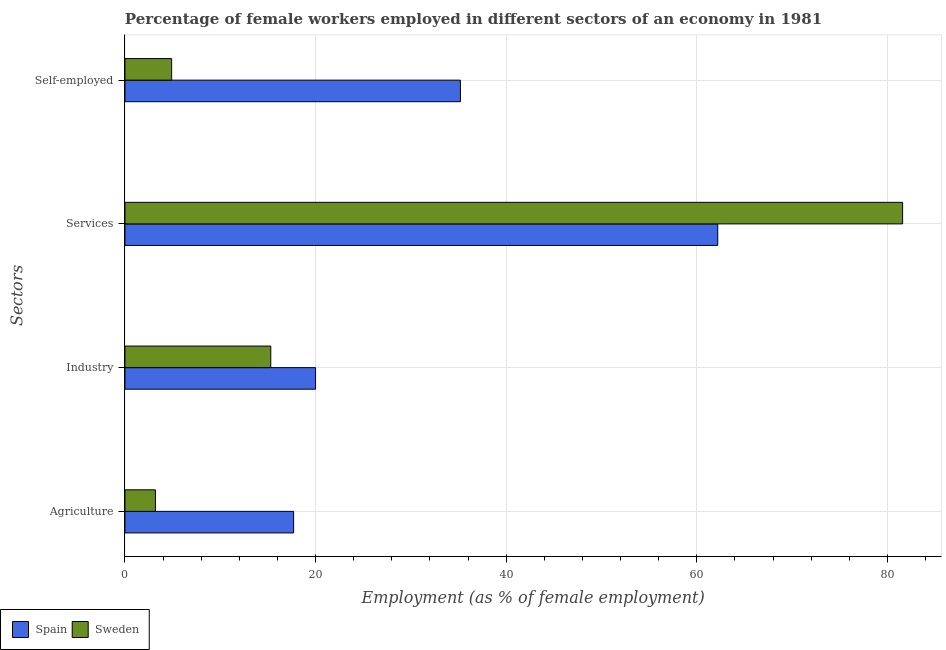How many groups of bars are there?
Your response must be concise. 4. Are the number of bars per tick equal to the number of legend labels?
Ensure brevity in your answer.  Yes. Are the number of bars on each tick of the Y-axis equal?
Your answer should be compact. Yes. How many bars are there on the 4th tick from the top?
Your answer should be compact. 2. What is the label of the 2nd group of bars from the top?
Provide a short and direct response. Services. What is the percentage of female workers in agriculture in Sweden?
Your answer should be compact. 3.2. Across all countries, what is the maximum percentage of self employed female workers?
Give a very brief answer. 35.2. Across all countries, what is the minimum percentage of female workers in agriculture?
Provide a succinct answer. 3.2. In which country was the percentage of female workers in services maximum?
Your response must be concise. Sweden. In which country was the percentage of female workers in industry minimum?
Give a very brief answer. Sweden. What is the total percentage of female workers in agriculture in the graph?
Your response must be concise. 20.9. What is the difference between the percentage of female workers in industry in Spain and that in Sweden?
Provide a succinct answer. 4.7. What is the difference between the percentage of female workers in industry in Sweden and the percentage of female workers in services in Spain?
Offer a terse response. -46.9. What is the average percentage of female workers in industry per country?
Your answer should be very brief. 17.65. What is the difference between the percentage of female workers in services and percentage of female workers in agriculture in Sweden?
Provide a short and direct response. 78.4. What is the ratio of the percentage of female workers in industry in Spain to that in Sweden?
Your answer should be compact. 1.31. Is the percentage of self employed female workers in Spain less than that in Sweden?
Give a very brief answer. No. Is the difference between the percentage of female workers in services in Spain and Sweden greater than the difference between the percentage of female workers in agriculture in Spain and Sweden?
Your answer should be very brief. No. What is the difference between the highest and the second highest percentage of self employed female workers?
Offer a terse response. 30.3. What is the difference between the highest and the lowest percentage of self employed female workers?
Provide a succinct answer. 30.3. In how many countries, is the percentage of female workers in agriculture greater than the average percentage of female workers in agriculture taken over all countries?
Make the answer very short. 1. Is it the case that in every country, the sum of the percentage of female workers in services and percentage of self employed female workers is greater than the sum of percentage of female workers in agriculture and percentage of female workers in industry?
Your answer should be very brief. Yes. Is it the case that in every country, the sum of the percentage of female workers in agriculture and percentage of female workers in industry is greater than the percentage of female workers in services?
Provide a succinct answer. No. How many bars are there?
Your answer should be very brief. 8. How many countries are there in the graph?
Provide a succinct answer. 2. Are the values on the major ticks of X-axis written in scientific E-notation?
Your response must be concise. No. Does the graph contain any zero values?
Offer a terse response. No. What is the title of the graph?
Your answer should be very brief. Percentage of female workers employed in different sectors of an economy in 1981. Does "Kosovo" appear as one of the legend labels in the graph?
Your response must be concise. No. What is the label or title of the X-axis?
Your response must be concise. Employment (as % of female employment). What is the label or title of the Y-axis?
Provide a short and direct response. Sectors. What is the Employment (as % of female employment) of Spain in Agriculture?
Your answer should be compact. 17.7. What is the Employment (as % of female employment) in Sweden in Agriculture?
Give a very brief answer. 3.2. What is the Employment (as % of female employment) of Spain in Industry?
Your answer should be very brief. 20. What is the Employment (as % of female employment) in Sweden in Industry?
Your response must be concise. 15.3. What is the Employment (as % of female employment) of Spain in Services?
Provide a short and direct response. 62.2. What is the Employment (as % of female employment) in Sweden in Services?
Your response must be concise. 81.6. What is the Employment (as % of female employment) of Spain in Self-employed?
Offer a terse response. 35.2. What is the Employment (as % of female employment) of Sweden in Self-employed?
Your answer should be compact. 4.9. Across all Sectors, what is the maximum Employment (as % of female employment) of Spain?
Provide a succinct answer. 62.2. Across all Sectors, what is the maximum Employment (as % of female employment) in Sweden?
Offer a terse response. 81.6. Across all Sectors, what is the minimum Employment (as % of female employment) in Spain?
Make the answer very short. 17.7. Across all Sectors, what is the minimum Employment (as % of female employment) in Sweden?
Offer a very short reply. 3.2. What is the total Employment (as % of female employment) in Spain in the graph?
Keep it short and to the point. 135.1. What is the total Employment (as % of female employment) of Sweden in the graph?
Give a very brief answer. 105. What is the difference between the Employment (as % of female employment) in Sweden in Agriculture and that in Industry?
Your answer should be very brief. -12.1. What is the difference between the Employment (as % of female employment) of Spain in Agriculture and that in Services?
Keep it short and to the point. -44.5. What is the difference between the Employment (as % of female employment) of Sweden in Agriculture and that in Services?
Provide a succinct answer. -78.4. What is the difference between the Employment (as % of female employment) in Spain in Agriculture and that in Self-employed?
Your response must be concise. -17.5. What is the difference between the Employment (as % of female employment) of Sweden in Agriculture and that in Self-employed?
Your answer should be very brief. -1.7. What is the difference between the Employment (as % of female employment) in Spain in Industry and that in Services?
Keep it short and to the point. -42.2. What is the difference between the Employment (as % of female employment) of Sweden in Industry and that in Services?
Offer a very short reply. -66.3. What is the difference between the Employment (as % of female employment) of Spain in Industry and that in Self-employed?
Make the answer very short. -15.2. What is the difference between the Employment (as % of female employment) in Sweden in Services and that in Self-employed?
Offer a very short reply. 76.7. What is the difference between the Employment (as % of female employment) of Spain in Agriculture and the Employment (as % of female employment) of Sweden in Industry?
Ensure brevity in your answer.  2.4. What is the difference between the Employment (as % of female employment) in Spain in Agriculture and the Employment (as % of female employment) in Sweden in Services?
Keep it short and to the point. -63.9. What is the difference between the Employment (as % of female employment) of Spain in Industry and the Employment (as % of female employment) of Sweden in Services?
Offer a terse response. -61.6. What is the difference between the Employment (as % of female employment) in Spain in Services and the Employment (as % of female employment) in Sweden in Self-employed?
Make the answer very short. 57.3. What is the average Employment (as % of female employment) of Spain per Sectors?
Offer a very short reply. 33.77. What is the average Employment (as % of female employment) in Sweden per Sectors?
Your answer should be very brief. 26.25. What is the difference between the Employment (as % of female employment) in Spain and Employment (as % of female employment) in Sweden in Agriculture?
Offer a terse response. 14.5. What is the difference between the Employment (as % of female employment) of Spain and Employment (as % of female employment) of Sweden in Services?
Ensure brevity in your answer.  -19.4. What is the difference between the Employment (as % of female employment) in Spain and Employment (as % of female employment) in Sweden in Self-employed?
Keep it short and to the point. 30.3. What is the ratio of the Employment (as % of female employment) in Spain in Agriculture to that in Industry?
Ensure brevity in your answer.  0.89. What is the ratio of the Employment (as % of female employment) in Sweden in Agriculture to that in Industry?
Your answer should be compact. 0.21. What is the ratio of the Employment (as % of female employment) in Spain in Agriculture to that in Services?
Offer a terse response. 0.28. What is the ratio of the Employment (as % of female employment) of Sweden in Agriculture to that in Services?
Make the answer very short. 0.04. What is the ratio of the Employment (as % of female employment) of Spain in Agriculture to that in Self-employed?
Your answer should be compact. 0.5. What is the ratio of the Employment (as % of female employment) in Sweden in Agriculture to that in Self-employed?
Make the answer very short. 0.65. What is the ratio of the Employment (as % of female employment) of Spain in Industry to that in Services?
Offer a very short reply. 0.32. What is the ratio of the Employment (as % of female employment) in Sweden in Industry to that in Services?
Ensure brevity in your answer.  0.19. What is the ratio of the Employment (as % of female employment) of Spain in Industry to that in Self-employed?
Offer a terse response. 0.57. What is the ratio of the Employment (as % of female employment) of Sweden in Industry to that in Self-employed?
Provide a succinct answer. 3.12. What is the ratio of the Employment (as % of female employment) in Spain in Services to that in Self-employed?
Offer a very short reply. 1.77. What is the ratio of the Employment (as % of female employment) of Sweden in Services to that in Self-employed?
Ensure brevity in your answer.  16.65. What is the difference between the highest and the second highest Employment (as % of female employment) of Spain?
Ensure brevity in your answer.  27. What is the difference between the highest and the second highest Employment (as % of female employment) of Sweden?
Make the answer very short. 66.3. What is the difference between the highest and the lowest Employment (as % of female employment) in Spain?
Offer a very short reply. 44.5. What is the difference between the highest and the lowest Employment (as % of female employment) in Sweden?
Provide a succinct answer. 78.4. 